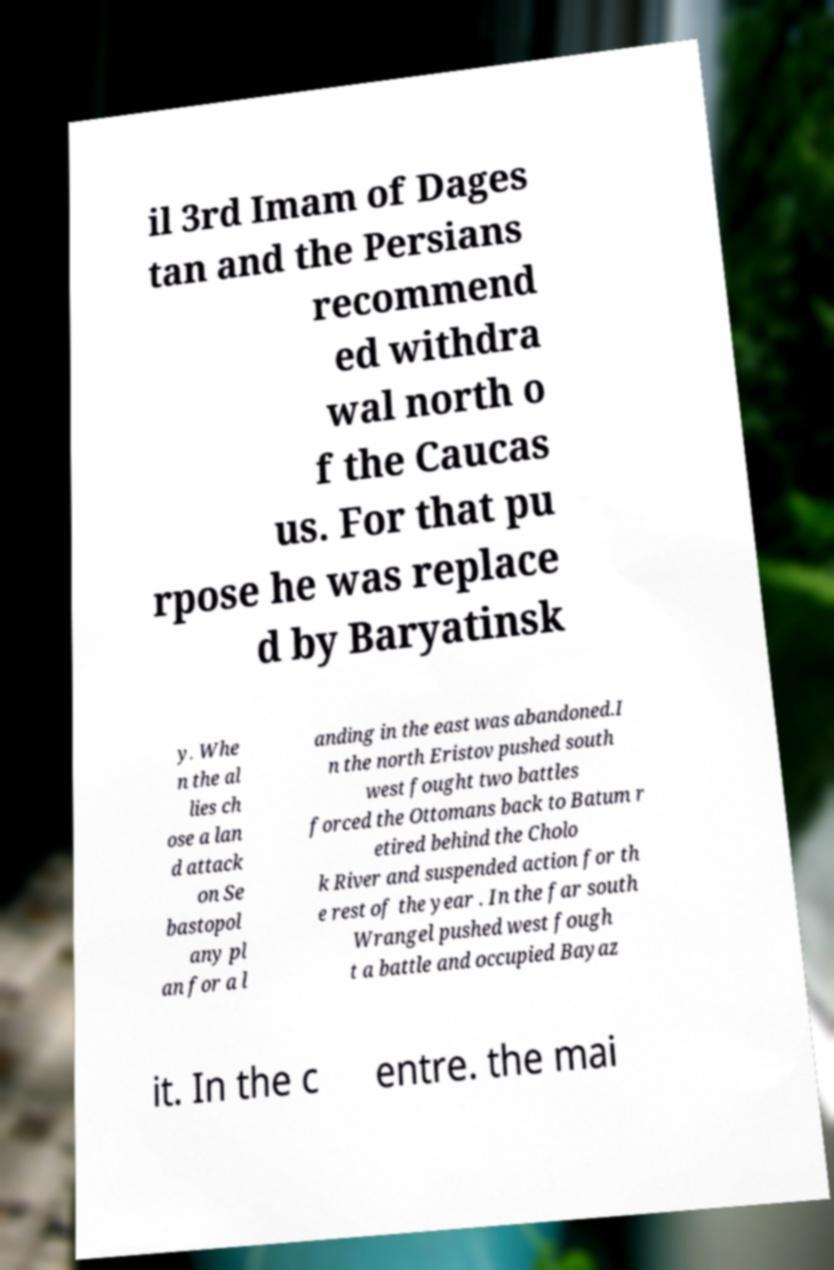There's text embedded in this image that I need extracted. Can you transcribe it verbatim? il 3rd Imam of Dages tan and the Persians recommend ed withdra wal north o f the Caucas us. For that pu rpose he was replace d by Baryatinsk y. Whe n the al lies ch ose a lan d attack on Se bastopol any pl an for a l anding in the east was abandoned.I n the north Eristov pushed south west fought two battles forced the Ottomans back to Batum r etired behind the Cholo k River and suspended action for th e rest of the year . In the far south Wrangel pushed west fough t a battle and occupied Bayaz it. In the c entre. the mai 